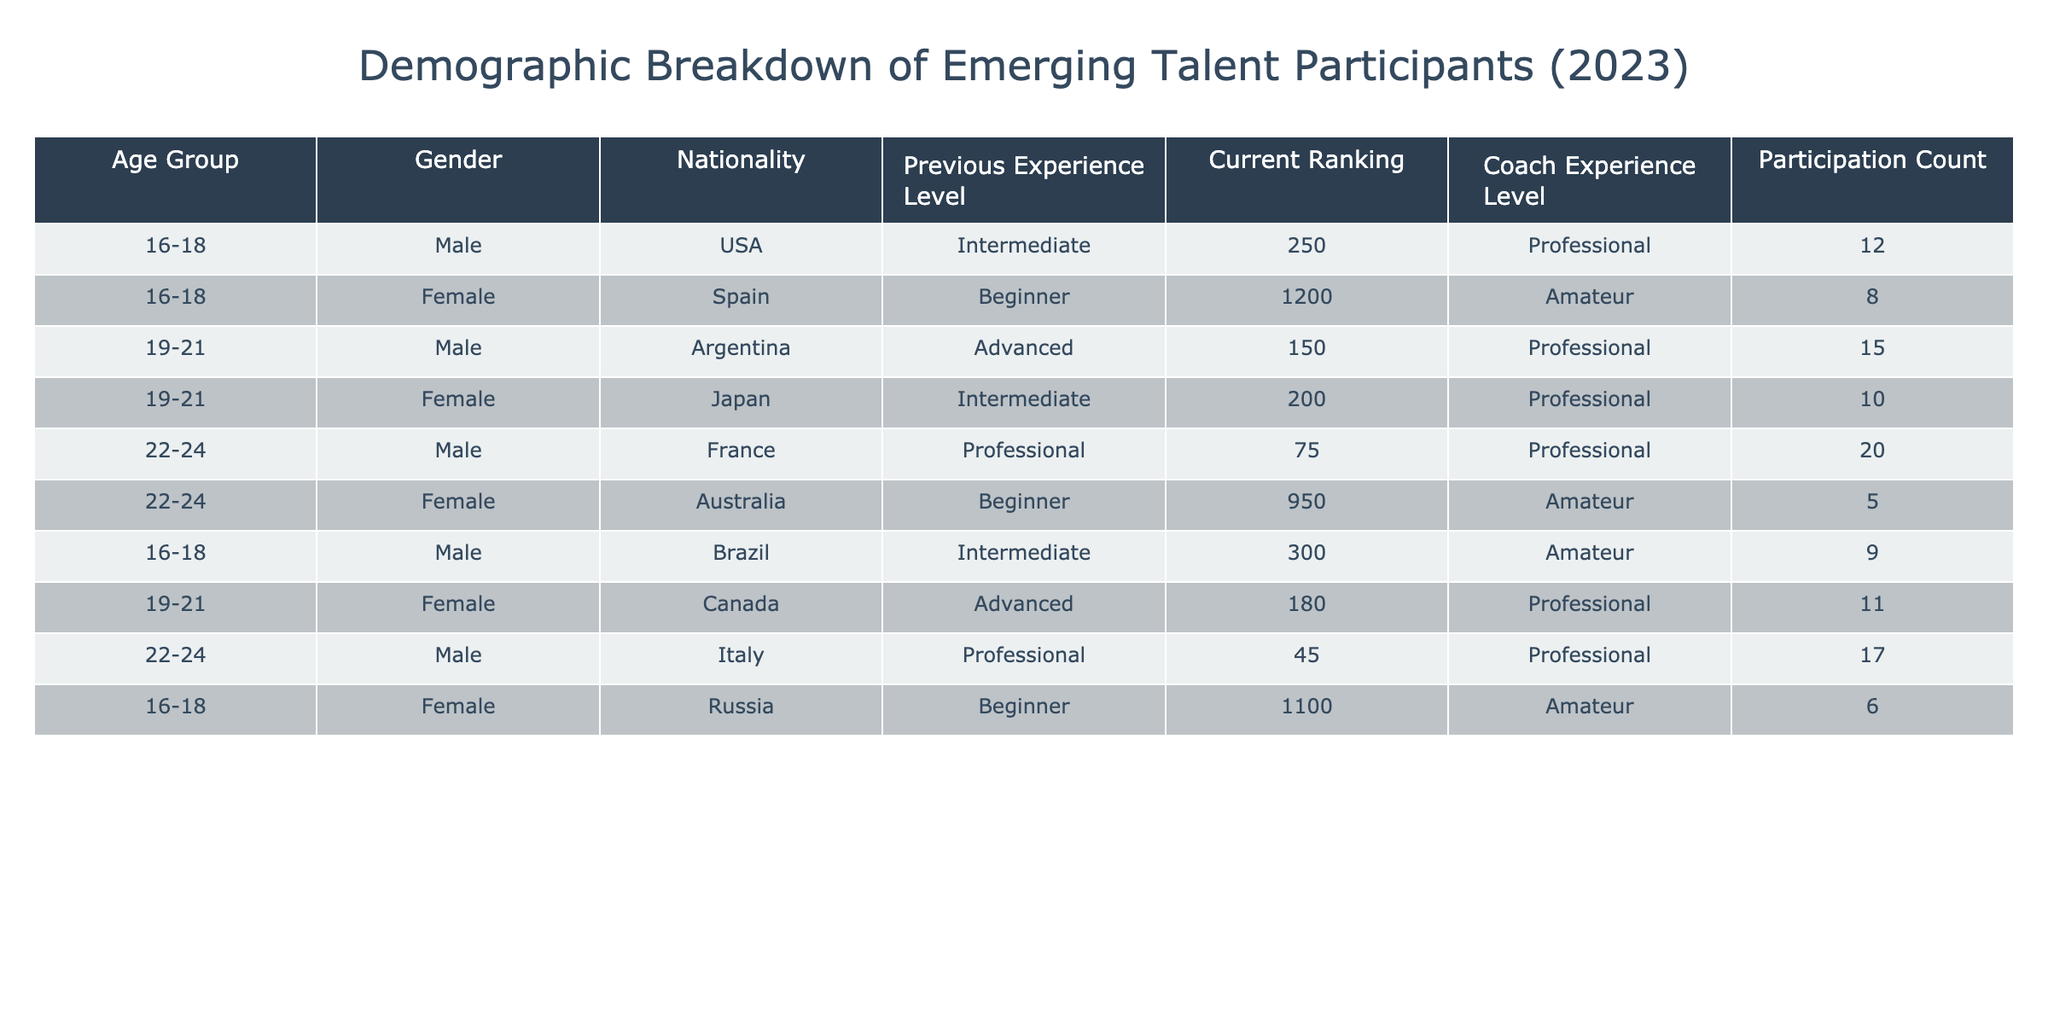What is the total participation count for male participants aged 19-21? There are 3 male participants aged 19-21 in the table. Their participation counts are 15 (Argentina), and 11 (Canada). Adding these together gives a total participation count of 15 + 11 = 26.
Answer: 26 Which age group has the highest overall participation count? To determine this, we need to sum the participation counts for each age group. The participation counts are: 16-18: 12 + 8 + 9 + 6 = 35; 19-21: 15 + 10 + 11 = 36; 22-24: 20 + 5 + 17 = 42. The highest participation count is in the 22-24 age group with 42 participants.
Answer: 22-24 Is there any emerging talent participant from Australia in the advanced experience level? Looking for a participant from Australia with an advanced experience level reveals that the participant listed from Australia (Female, 22-24) is at the Beginner level and not Advanced. Thus, there is no participant fitting the criteria.
Answer: No How many female participants are there with professional coach experience level? To find female participants with a professional coach experience level, we filter the table for the Female gender and Professional coach experience. The valid entries are the 16-18 Female (Japan) and the 19-21 Female (Canada), resulting in a total of 3 female participants with professional coach experience.
Answer: 3 What is the average ranking of male participants aged 22-24? There are 3 male participants aged 22-24, with rankings of 75 (France), 45 (Italy), and 17 (USA). We calculate the average by adding them: 75 + 45 + 20 = 140, then divide by 3: 140 / 3 = approximately 46.67.
Answer: Approximately 46.67 